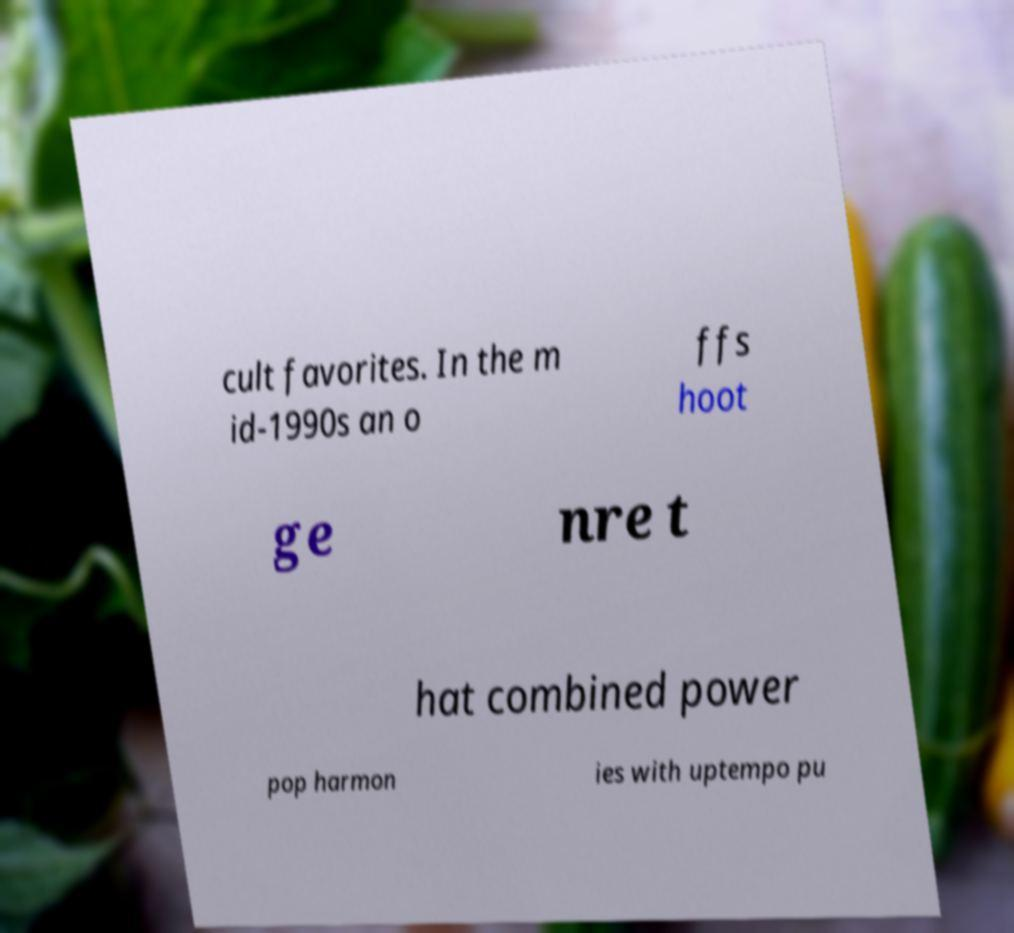I need the written content from this picture converted into text. Can you do that? cult favorites. In the m id-1990s an o ffs hoot ge nre t hat combined power pop harmon ies with uptempo pu 